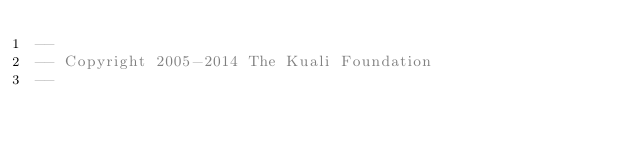<code> <loc_0><loc_0><loc_500><loc_500><_SQL_>--
-- Copyright 2005-2014 The Kuali Foundation
--</code> 